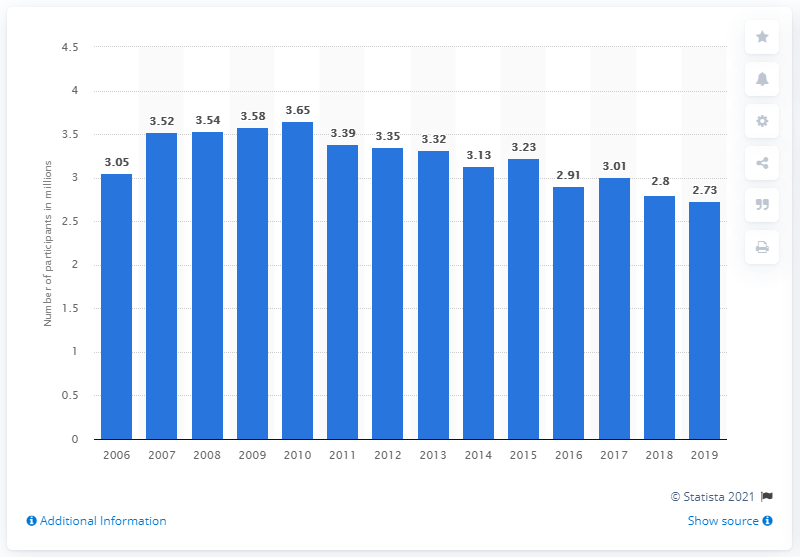Identify some key points in this picture. In 2019, approximately 2.73 million individuals participated in wakeboarding in the United States. 